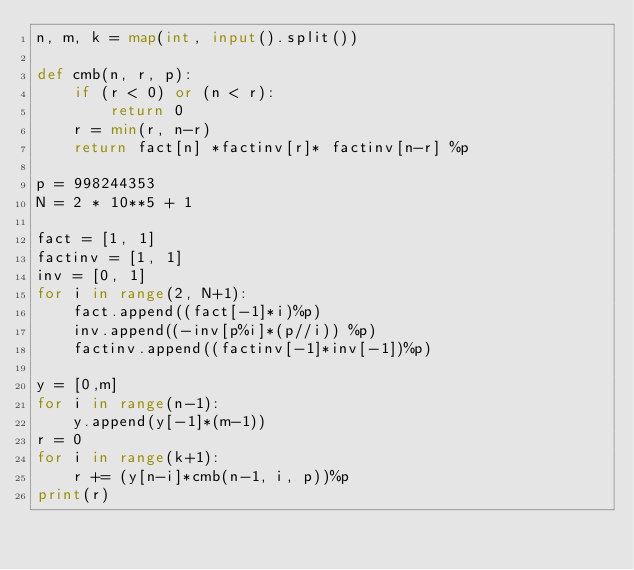Convert code to text. <code><loc_0><loc_0><loc_500><loc_500><_Python_>n, m, k = map(int, input().split())

def cmb(n, r, p):
    if (r < 0) or (n < r):
        return 0
    r = min(r, n-r)
    return fact[n] *factinv[r]* factinv[n-r] %p

p = 998244353
N = 2 * 10**5 + 1

fact = [1, 1]
factinv = [1, 1]
inv = [0, 1]
for i in range(2, N+1):
    fact.append((fact[-1]*i)%p)
    inv.append((-inv[p%i]*(p//i)) %p)
    factinv.append((factinv[-1]*inv[-1])%p)

y = [0,m]
for i in range(n-1):
    y.append(y[-1]*(m-1))
r = 0
for i in range(k+1):
    r += (y[n-i]*cmb(n-1, i, p))%p
print(r)</code> 